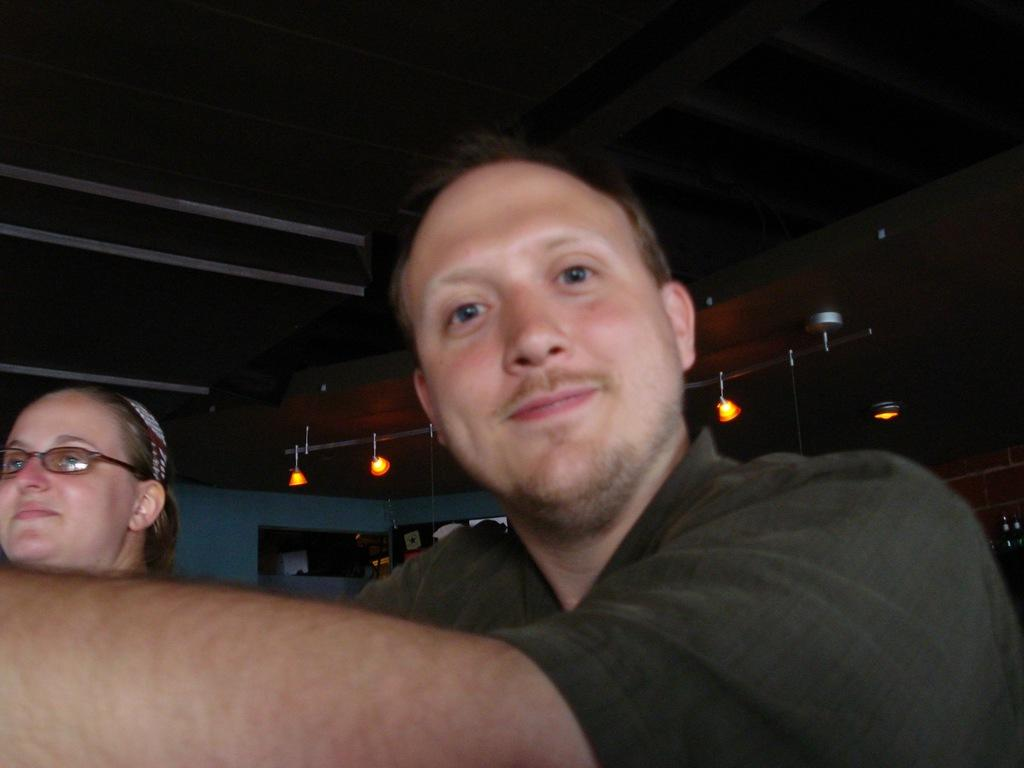How many people are in the image? There are two people in the image. What can be seen above the people in the image? There is a ceiling visible in the image. What type of illumination is present in the image? There are lights in the image. What is visible behind the people in the image? There is a wall in the background of the image. What type of needle is being used for teaching in the image? There is no needle or teaching activity present in the image. 